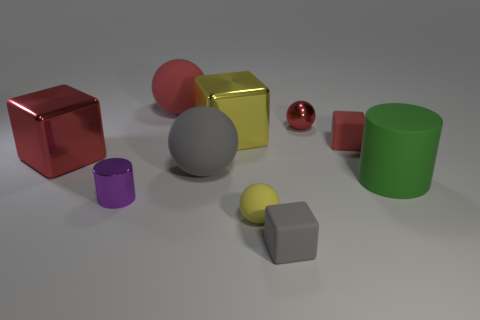Subtract all green balls. How many red cubes are left? 2 Subtract all gray blocks. How many blocks are left? 3 Subtract all green cubes. Subtract all red cylinders. How many cubes are left? 4 Add 7 big yellow balls. How many big yellow balls exist? 7 Subtract 0 yellow cylinders. How many objects are left? 10 Subtract all cubes. How many objects are left? 6 Subtract all large blue shiny cylinders. Subtract all yellow metallic objects. How many objects are left? 9 Add 3 metallic spheres. How many metallic spheres are left? 4 